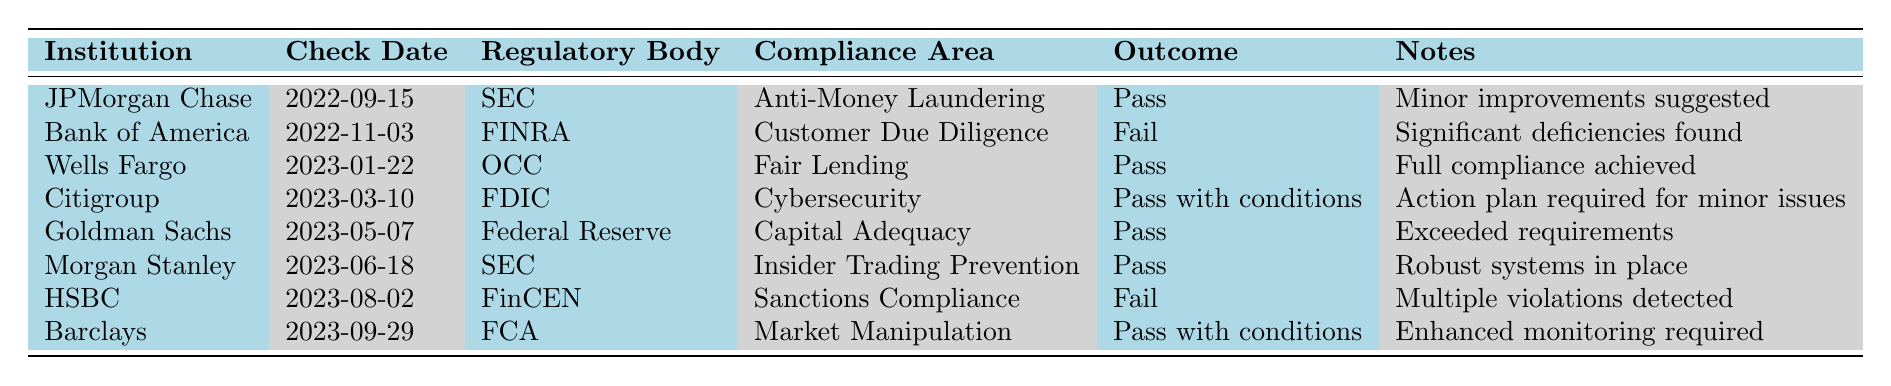What date was the compliance check for HSBC? The table indicates that the compliance check for HSBC occurred on August 2, 2023, as listed under the Check Date column for that institution.
Answer: August 2, 2023 Which institution had a compliance check with the outcome "Fail"? There are two institutions with a "Fail" outcome in the table: Bank of America and HSBC. I can identify them by looking at the Outcome column for each institution.
Answer: Bank of America, HSBC What regulatory body conducted the compliance check for Citigroup? The table shows that the regulatory body for Citigroup's compliance check is the FDIC, mentioned in the Regulatory Body column next to Citigroup.
Answer: FDIC How many institutions passed all their compliance areas? The institutions that passed all their checks are JPMorgan Chase, Wells Fargo, Goldman Sachs, and Morgan Stanley, totaling four institutions by counting them in the Outcome column where it lists "Pass."
Answer: 4 Did Barclays have any conditions associated with their compliance outcome? Yes, the Outcome for Barclays states "Pass with conditions," which suggests that their compliance was approved but with some requirements for improvement; this information can be confirmed by reviewing the Notes.
Answer: Yes What is the sum of outcomes classified as "Fail" for compliance checks? There are two outcomes classified as "Fail" in the table (from Bank of America and HSBC), and since these are categorical outcomes, they don't equate to numerical values, meaning the sum isn't applicable here.
Answer: 0 How does the outcome of Goldman Sachs compare to that of Bank of America? Goldman Sachs passed their compliance check, while Bank of America failed theirs, as seen in the Outcome column of each respective row in the table.
Answer: Goldman Sachs passed; Bank of America failed Which compliance area had the most recent check, and what was the outcome? The most recent check listed in the table is for Barclays under Market Manipulation, dated September 29, 2023, with an outcome of "Pass with conditions," found by looking for the latest date in the Check Date column.
Answer: Market Manipulation; Pass with conditions What percentage of institutions had outcomes classified as "Pass"? There are 6 out of 8 institutions that passed (considering "Pass" and "Pass with conditions" as passing), which can be calculated by (6/8) * 100 = 75%.
Answer: 75% If an institution failed a compliance check, what are the common notes given? The common notes given for the failures (Bank of America and HSBC) mention significant deficiencies and multiple violations, respectively, found by reviewing the Notes column for each failed outcome.
Answer: Significant deficiencies; multiple violations 